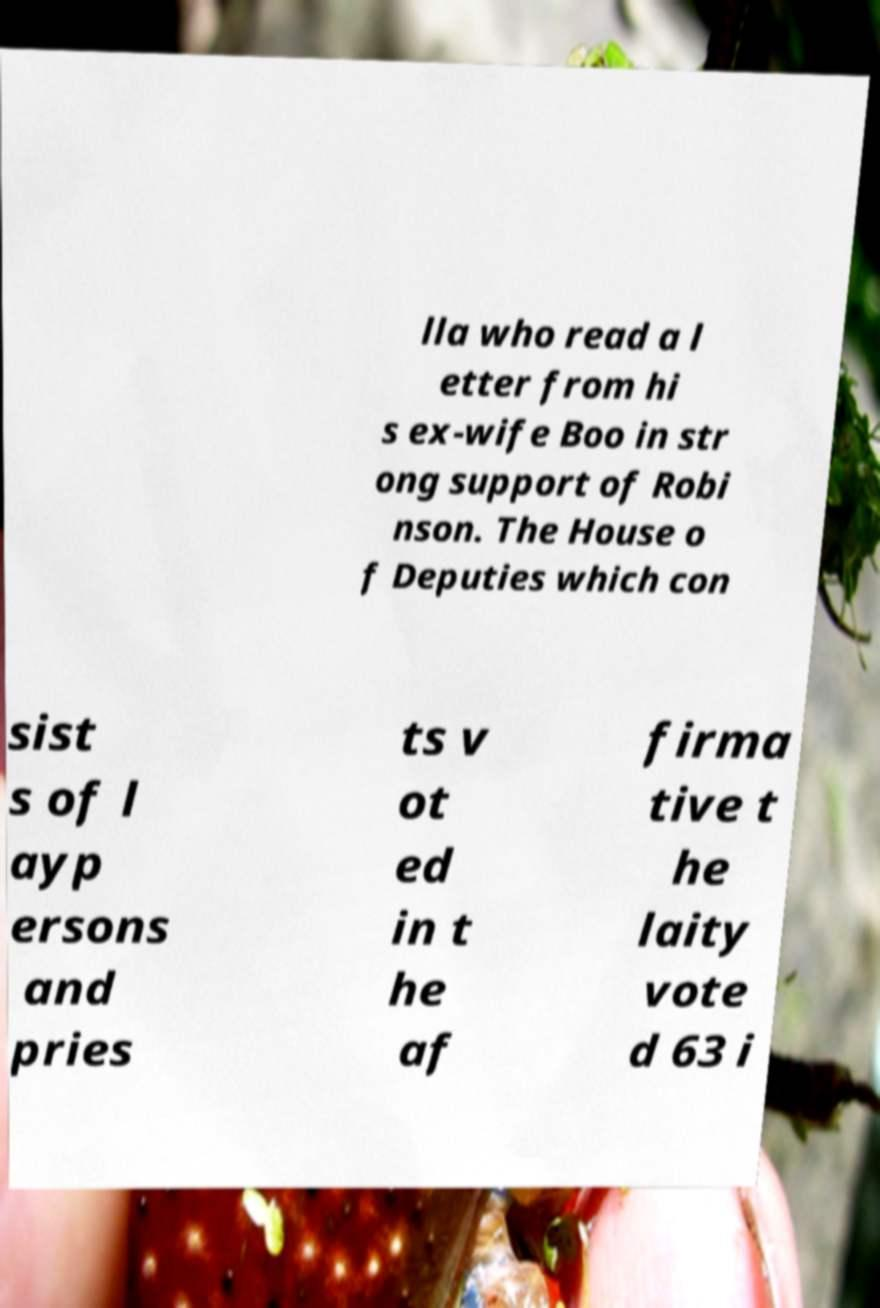Please identify and transcribe the text found in this image. lla who read a l etter from hi s ex-wife Boo in str ong support of Robi nson. The House o f Deputies which con sist s of l ayp ersons and pries ts v ot ed in t he af firma tive t he laity vote d 63 i 